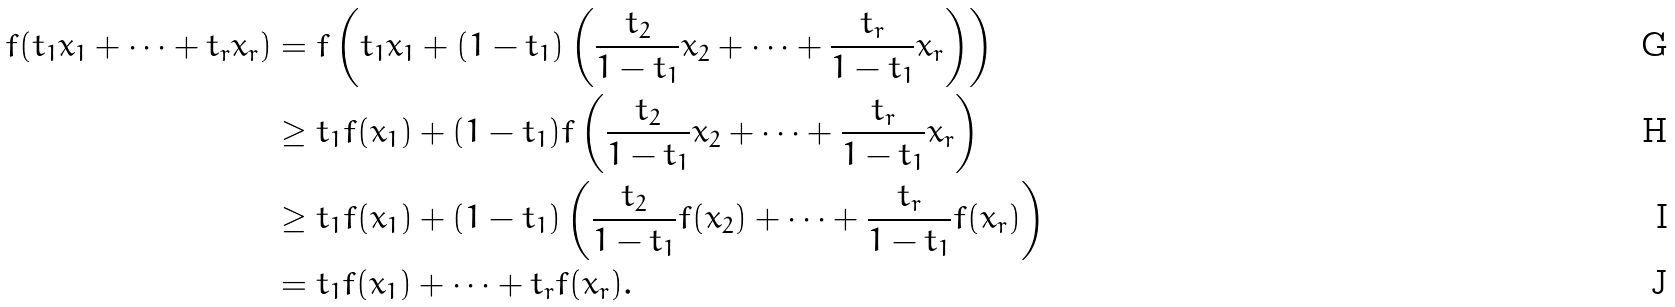<formula> <loc_0><loc_0><loc_500><loc_500>f ( t _ { 1 } x _ { 1 } + \cdots + t _ { r } x _ { r } ) & = f \left ( t _ { 1 } x _ { 1 } + ( 1 - t _ { 1 } ) \left ( \frac { t _ { 2 } } { 1 - t _ { 1 } } x _ { 2 } + \cdots + \frac { t _ { r } } { 1 - t _ { 1 } } x _ { r } \right ) \right ) \\ & \geq t _ { 1 } f ( x _ { 1 } ) + ( 1 - t _ { 1 } ) f \left ( \frac { t _ { 2 } } { 1 - t _ { 1 } } x _ { 2 } + \cdots + \frac { t _ { r } } { 1 - t _ { 1 } } x _ { r } \right ) \\ & \geq t _ { 1 } f ( x _ { 1 } ) + ( 1 - t _ { 1 } ) \left ( \frac { t _ { 2 } } { 1 - t _ { 1 } } f ( x _ { 2 } ) + \cdots + \frac { t _ { r } } { 1 - t _ { 1 } } f ( x _ { r } ) \right ) \\ & = t _ { 1 } f ( x _ { 1 } ) + \cdots + t _ { r } f ( x _ { r } ) .</formula> 